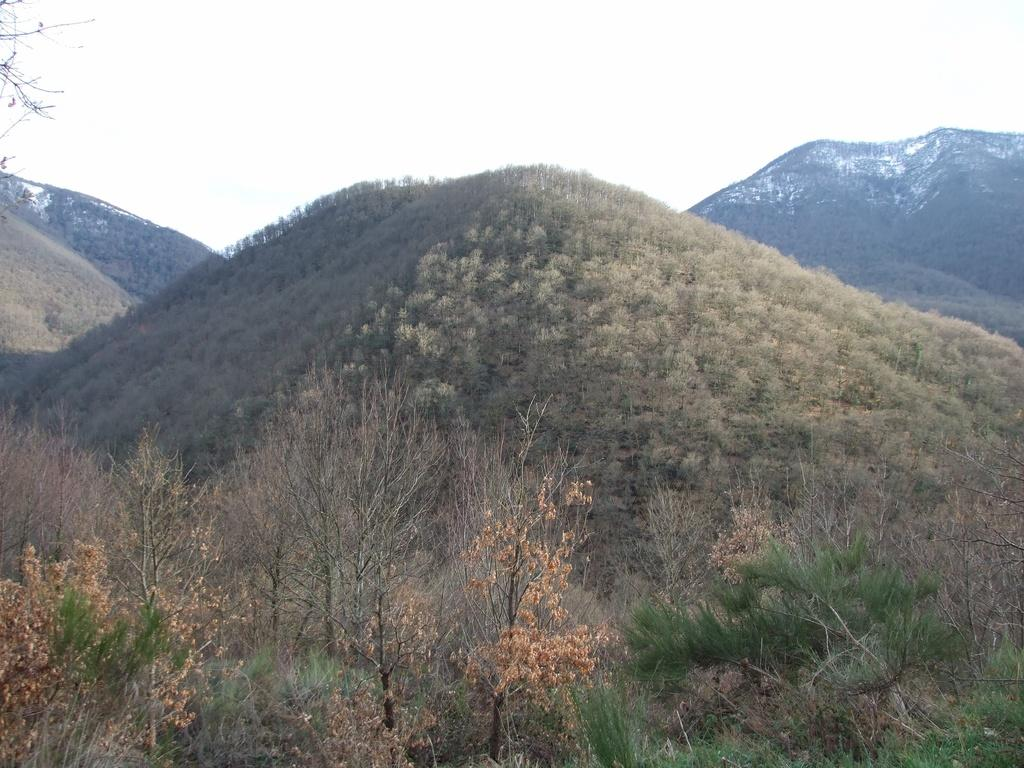What type of vegetation is present at the bottom of the image? There are trees at the bottom of the image. What type of landscape feature can be seen in the background of the image? There are hills in the background of the image. What is visible at the top of the image? The sky is visible at the top of the image. What type of game is being played by the parent wearing a shirt in the image? There is no game, parent, or shirt present in the image. 